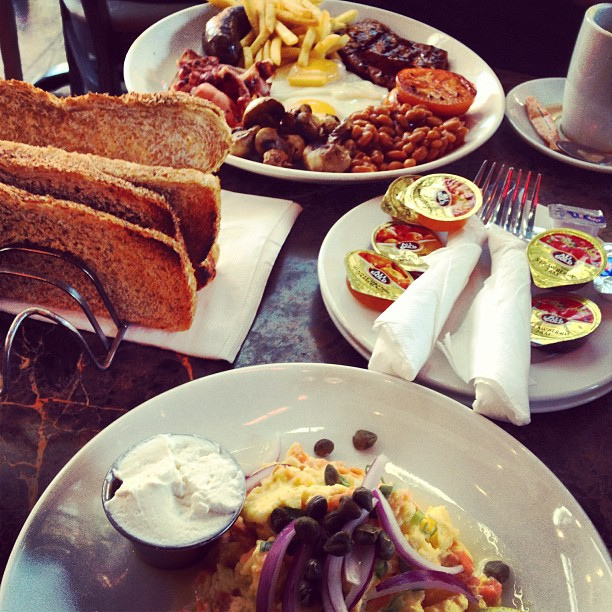Describe the cup on the table. What do you think is inside it? The cup on the table appears to be a ceramic mug, likely containing coffee or tea, given the context of a breakfast setting. 